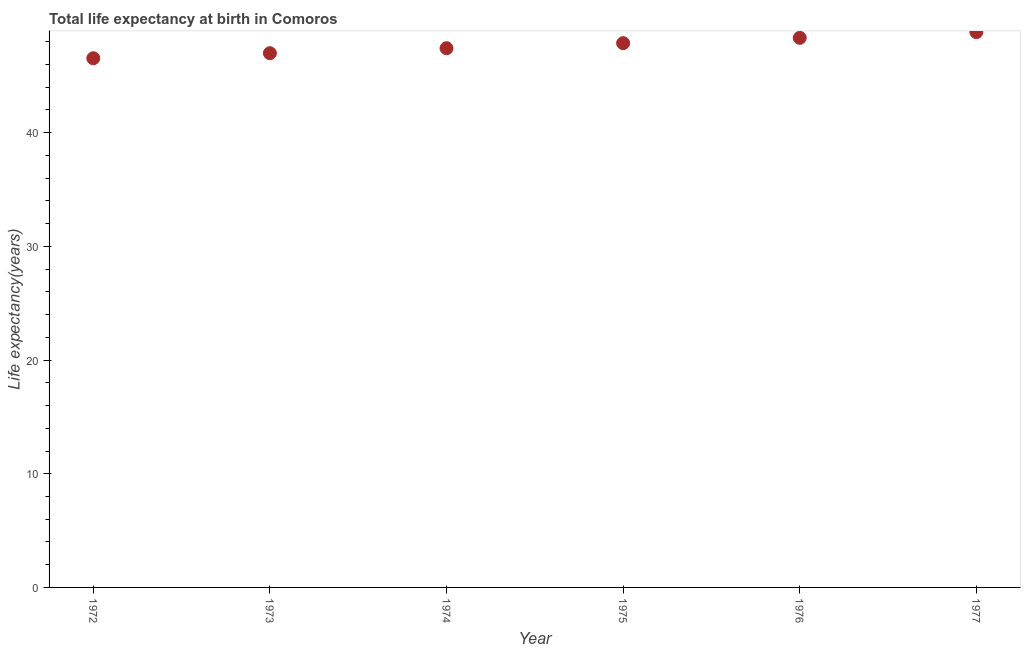What is the life expectancy at birth in 1975?
Provide a succinct answer. 47.88. Across all years, what is the maximum life expectancy at birth?
Your answer should be compact. 48.85. Across all years, what is the minimum life expectancy at birth?
Make the answer very short. 46.55. In which year was the life expectancy at birth minimum?
Keep it short and to the point. 1972. What is the sum of the life expectancy at birth?
Provide a succinct answer. 286.03. What is the difference between the life expectancy at birth in 1972 and 1975?
Ensure brevity in your answer.  -1.33. What is the average life expectancy at birth per year?
Your answer should be compact. 47.67. What is the median life expectancy at birth?
Offer a terse response. 47.65. In how many years, is the life expectancy at birth greater than 32 years?
Your answer should be very brief. 6. Do a majority of the years between 1975 and 1972 (inclusive) have life expectancy at birth greater than 44 years?
Provide a short and direct response. Yes. What is the ratio of the life expectancy at birth in 1975 to that in 1977?
Ensure brevity in your answer.  0.98. What is the difference between the highest and the second highest life expectancy at birth?
Your answer should be compact. 0.5. What is the difference between the highest and the lowest life expectancy at birth?
Your answer should be very brief. 2.3. How many years are there in the graph?
Keep it short and to the point. 6. What is the difference between two consecutive major ticks on the Y-axis?
Your answer should be very brief. 10. Are the values on the major ticks of Y-axis written in scientific E-notation?
Offer a terse response. No. Does the graph contain grids?
Provide a short and direct response. No. What is the title of the graph?
Ensure brevity in your answer.  Total life expectancy at birth in Comoros. What is the label or title of the X-axis?
Make the answer very short. Year. What is the label or title of the Y-axis?
Provide a short and direct response. Life expectancy(years). What is the Life expectancy(years) in 1972?
Give a very brief answer. 46.55. What is the Life expectancy(years) in 1973?
Provide a short and direct response. 46.99. What is the Life expectancy(years) in 1974?
Your response must be concise. 47.43. What is the Life expectancy(years) in 1975?
Ensure brevity in your answer.  47.88. What is the Life expectancy(years) in 1976?
Your response must be concise. 48.34. What is the Life expectancy(years) in 1977?
Offer a terse response. 48.85. What is the difference between the Life expectancy(years) in 1972 and 1973?
Your response must be concise. -0.44. What is the difference between the Life expectancy(years) in 1972 and 1974?
Provide a short and direct response. -0.88. What is the difference between the Life expectancy(years) in 1972 and 1975?
Your answer should be compact. -1.33. What is the difference between the Life expectancy(years) in 1972 and 1976?
Your response must be concise. -1.8. What is the difference between the Life expectancy(years) in 1972 and 1977?
Provide a short and direct response. -2.3. What is the difference between the Life expectancy(years) in 1973 and 1974?
Your response must be concise. -0.44. What is the difference between the Life expectancy(years) in 1973 and 1975?
Offer a very short reply. -0.88. What is the difference between the Life expectancy(years) in 1973 and 1976?
Give a very brief answer. -1.35. What is the difference between the Life expectancy(years) in 1973 and 1977?
Offer a very short reply. -1.85. What is the difference between the Life expectancy(years) in 1974 and 1975?
Your response must be concise. -0.44. What is the difference between the Life expectancy(years) in 1974 and 1976?
Your answer should be very brief. -0.91. What is the difference between the Life expectancy(years) in 1974 and 1977?
Provide a short and direct response. -1.41. What is the difference between the Life expectancy(years) in 1975 and 1976?
Your answer should be compact. -0.47. What is the difference between the Life expectancy(years) in 1975 and 1977?
Provide a succinct answer. -0.97. What is the difference between the Life expectancy(years) in 1976 and 1977?
Provide a short and direct response. -0.5. What is the ratio of the Life expectancy(years) in 1972 to that in 1973?
Give a very brief answer. 0.99. What is the ratio of the Life expectancy(years) in 1972 to that in 1975?
Your answer should be very brief. 0.97. What is the ratio of the Life expectancy(years) in 1972 to that in 1977?
Make the answer very short. 0.95. What is the ratio of the Life expectancy(years) in 1973 to that in 1975?
Ensure brevity in your answer.  0.98. What is the ratio of the Life expectancy(years) in 1973 to that in 1976?
Provide a succinct answer. 0.97. What is the ratio of the Life expectancy(years) in 1973 to that in 1977?
Provide a short and direct response. 0.96. What is the ratio of the Life expectancy(years) in 1974 to that in 1976?
Your response must be concise. 0.98. What is the ratio of the Life expectancy(years) in 1974 to that in 1977?
Make the answer very short. 0.97. 